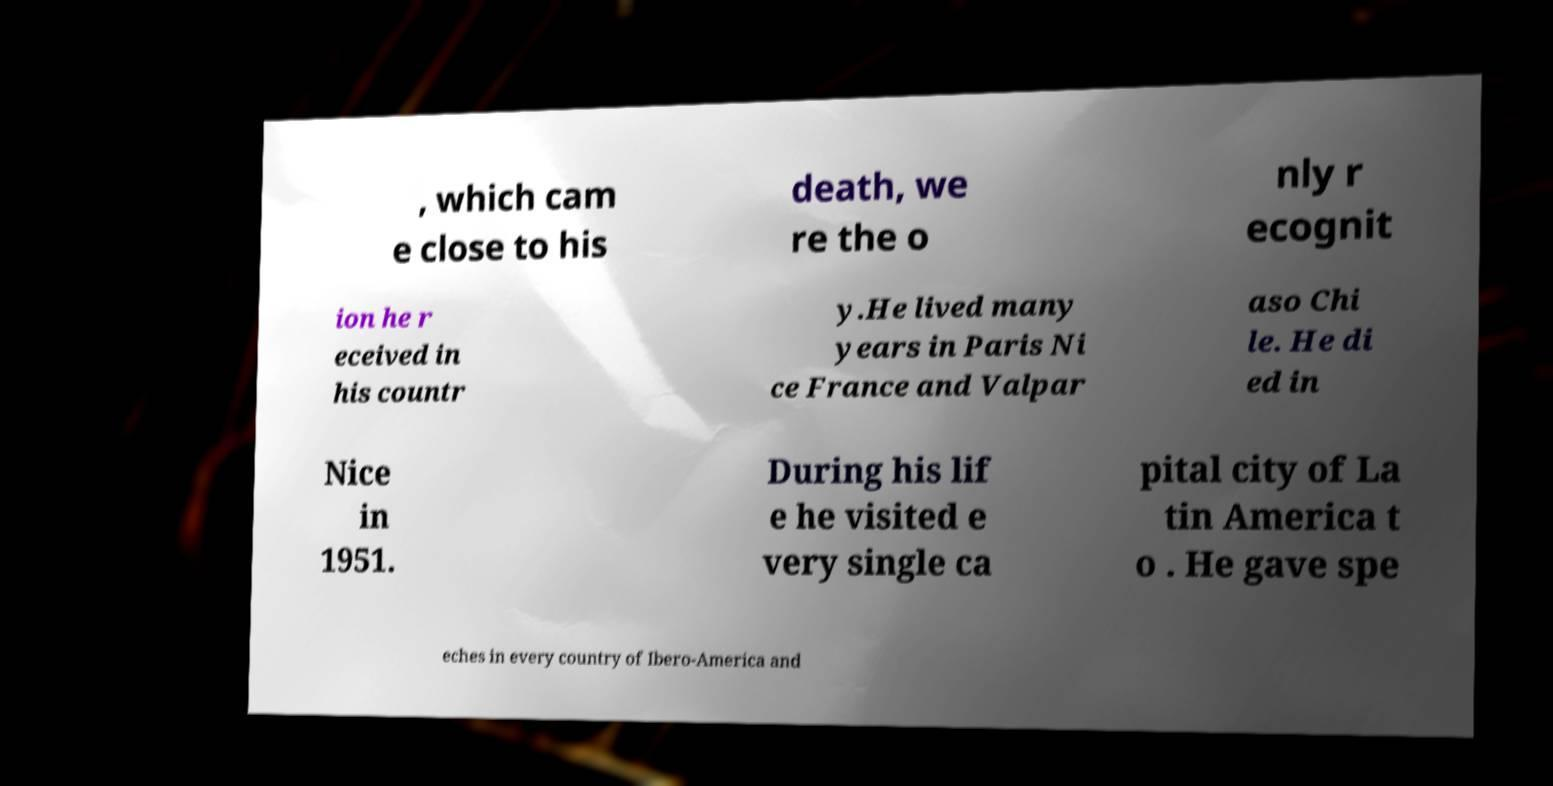Could you assist in decoding the text presented in this image and type it out clearly? , which cam e close to his death, we re the o nly r ecognit ion he r eceived in his countr y.He lived many years in Paris Ni ce France and Valpar aso Chi le. He di ed in Nice in 1951. During his lif e he visited e very single ca pital city of La tin America t o . He gave spe eches in every country of Ibero-America and 